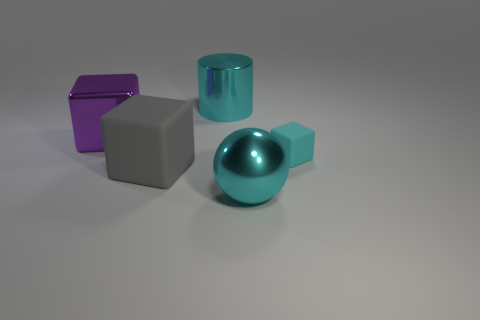Add 2 gray blocks. How many objects exist? 7 Subtract 1 cyan cubes. How many objects are left? 4 Subtract all cubes. How many objects are left? 2 Subtract 1 spheres. How many spheres are left? 0 Subtract all blue cylinders. Subtract all yellow blocks. How many cylinders are left? 1 Subtract all green spheres. How many cyan blocks are left? 1 Subtract all cyan metal balls. Subtract all small things. How many objects are left? 3 Add 1 rubber things. How many rubber things are left? 3 Add 5 large cyan cylinders. How many large cyan cylinders exist? 6 Subtract all purple blocks. How many blocks are left? 2 